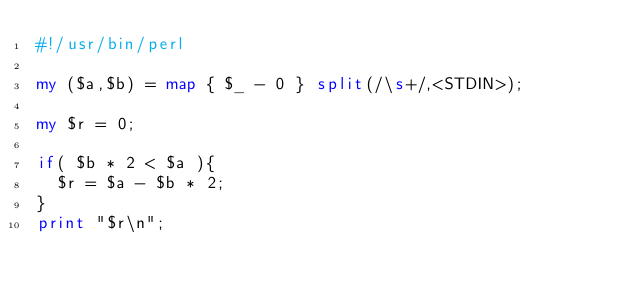Convert code to text. <code><loc_0><loc_0><loc_500><loc_500><_Perl_>#!/usr/bin/perl

my ($a,$b) = map { $_ - 0 } split(/\s+/,<STDIN>);

my $r = 0;

if( $b * 2 < $a ){
  $r = $a - $b * 2;
}
print "$r\n";




</code> 